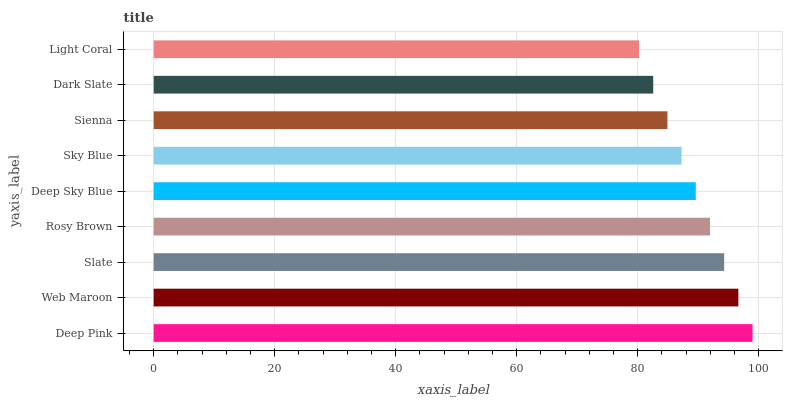Is Light Coral the minimum?
Answer yes or no. Yes. Is Deep Pink the maximum?
Answer yes or no. Yes. Is Web Maroon the minimum?
Answer yes or no. No. Is Web Maroon the maximum?
Answer yes or no. No. Is Deep Pink greater than Web Maroon?
Answer yes or no. Yes. Is Web Maroon less than Deep Pink?
Answer yes or no. Yes. Is Web Maroon greater than Deep Pink?
Answer yes or no. No. Is Deep Pink less than Web Maroon?
Answer yes or no. No. Is Deep Sky Blue the high median?
Answer yes or no. Yes. Is Deep Sky Blue the low median?
Answer yes or no. Yes. Is Web Maroon the high median?
Answer yes or no. No. Is Deep Pink the low median?
Answer yes or no. No. 